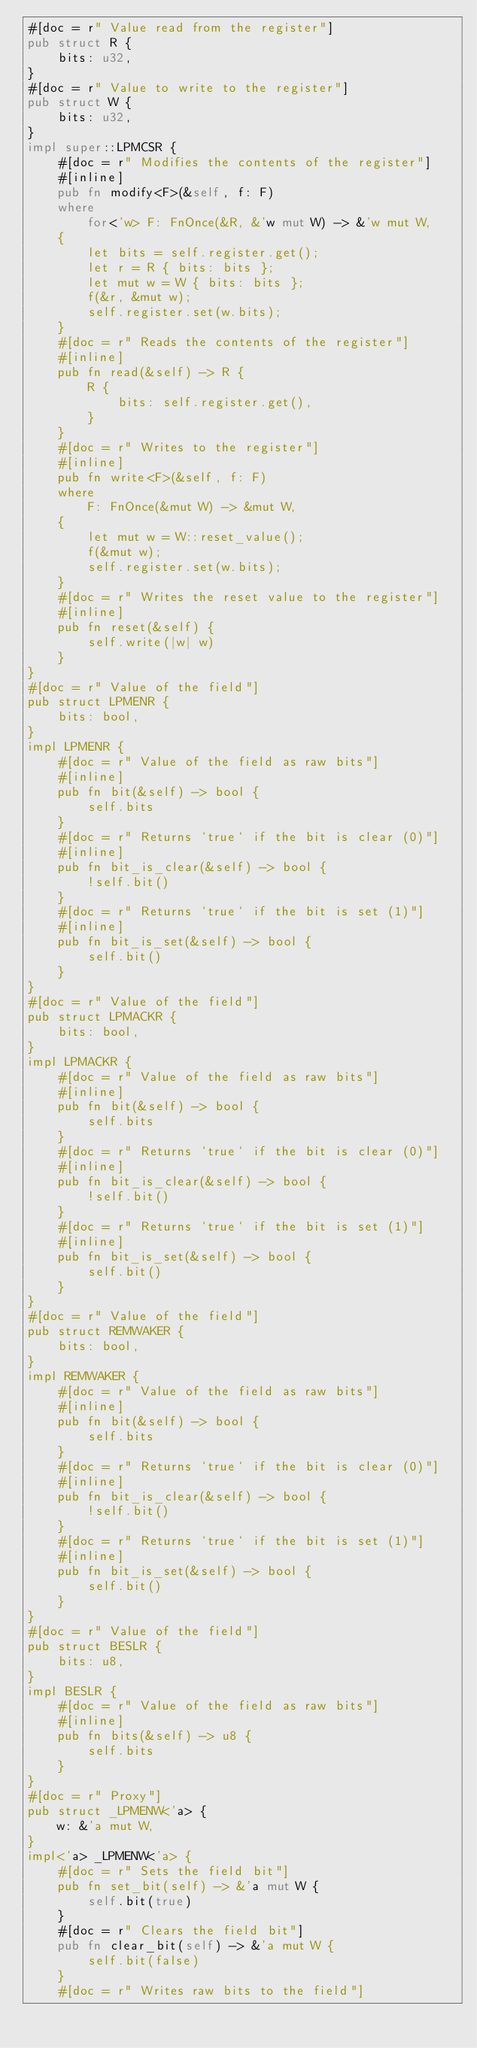Convert code to text. <code><loc_0><loc_0><loc_500><loc_500><_Rust_>#[doc = r" Value read from the register"]
pub struct R {
    bits: u32,
}
#[doc = r" Value to write to the register"]
pub struct W {
    bits: u32,
}
impl super::LPMCSR {
    #[doc = r" Modifies the contents of the register"]
    #[inline]
    pub fn modify<F>(&self, f: F)
    where
        for<'w> F: FnOnce(&R, &'w mut W) -> &'w mut W,
    {
        let bits = self.register.get();
        let r = R { bits: bits };
        let mut w = W { bits: bits };
        f(&r, &mut w);
        self.register.set(w.bits);
    }
    #[doc = r" Reads the contents of the register"]
    #[inline]
    pub fn read(&self) -> R {
        R {
            bits: self.register.get(),
        }
    }
    #[doc = r" Writes to the register"]
    #[inline]
    pub fn write<F>(&self, f: F)
    where
        F: FnOnce(&mut W) -> &mut W,
    {
        let mut w = W::reset_value();
        f(&mut w);
        self.register.set(w.bits);
    }
    #[doc = r" Writes the reset value to the register"]
    #[inline]
    pub fn reset(&self) {
        self.write(|w| w)
    }
}
#[doc = r" Value of the field"]
pub struct LPMENR {
    bits: bool,
}
impl LPMENR {
    #[doc = r" Value of the field as raw bits"]
    #[inline]
    pub fn bit(&self) -> bool {
        self.bits
    }
    #[doc = r" Returns `true` if the bit is clear (0)"]
    #[inline]
    pub fn bit_is_clear(&self) -> bool {
        !self.bit()
    }
    #[doc = r" Returns `true` if the bit is set (1)"]
    #[inline]
    pub fn bit_is_set(&self) -> bool {
        self.bit()
    }
}
#[doc = r" Value of the field"]
pub struct LPMACKR {
    bits: bool,
}
impl LPMACKR {
    #[doc = r" Value of the field as raw bits"]
    #[inline]
    pub fn bit(&self) -> bool {
        self.bits
    }
    #[doc = r" Returns `true` if the bit is clear (0)"]
    #[inline]
    pub fn bit_is_clear(&self) -> bool {
        !self.bit()
    }
    #[doc = r" Returns `true` if the bit is set (1)"]
    #[inline]
    pub fn bit_is_set(&self) -> bool {
        self.bit()
    }
}
#[doc = r" Value of the field"]
pub struct REMWAKER {
    bits: bool,
}
impl REMWAKER {
    #[doc = r" Value of the field as raw bits"]
    #[inline]
    pub fn bit(&self) -> bool {
        self.bits
    }
    #[doc = r" Returns `true` if the bit is clear (0)"]
    #[inline]
    pub fn bit_is_clear(&self) -> bool {
        !self.bit()
    }
    #[doc = r" Returns `true` if the bit is set (1)"]
    #[inline]
    pub fn bit_is_set(&self) -> bool {
        self.bit()
    }
}
#[doc = r" Value of the field"]
pub struct BESLR {
    bits: u8,
}
impl BESLR {
    #[doc = r" Value of the field as raw bits"]
    #[inline]
    pub fn bits(&self) -> u8 {
        self.bits
    }
}
#[doc = r" Proxy"]
pub struct _LPMENW<'a> {
    w: &'a mut W,
}
impl<'a> _LPMENW<'a> {
    #[doc = r" Sets the field bit"]
    pub fn set_bit(self) -> &'a mut W {
        self.bit(true)
    }
    #[doc = r" Clears the field bit"]
    pub fn clear_bit(self) -> &'a mut W {
        self.bit(false)
    }
    #[doc = r" Writes raw bits to the field"]</code> 